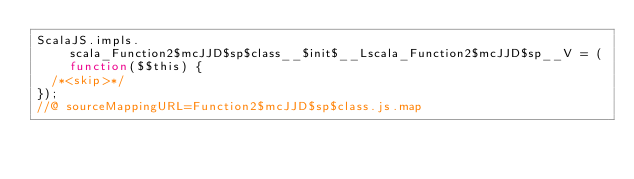Convert code to text. <code><loc_0><loc_0><loc_500><loc_500><_JavaScript_>ScalaJS.impls.scala_Function2$mcJJD$sp$class__$init$__Lscala_Function2$mcJJD$sp__V = (function($$this) {
  /*<skip>*/
});
//@ sourceMappingURL=Function2$mcJJD$sp$class.js.map
</code> 